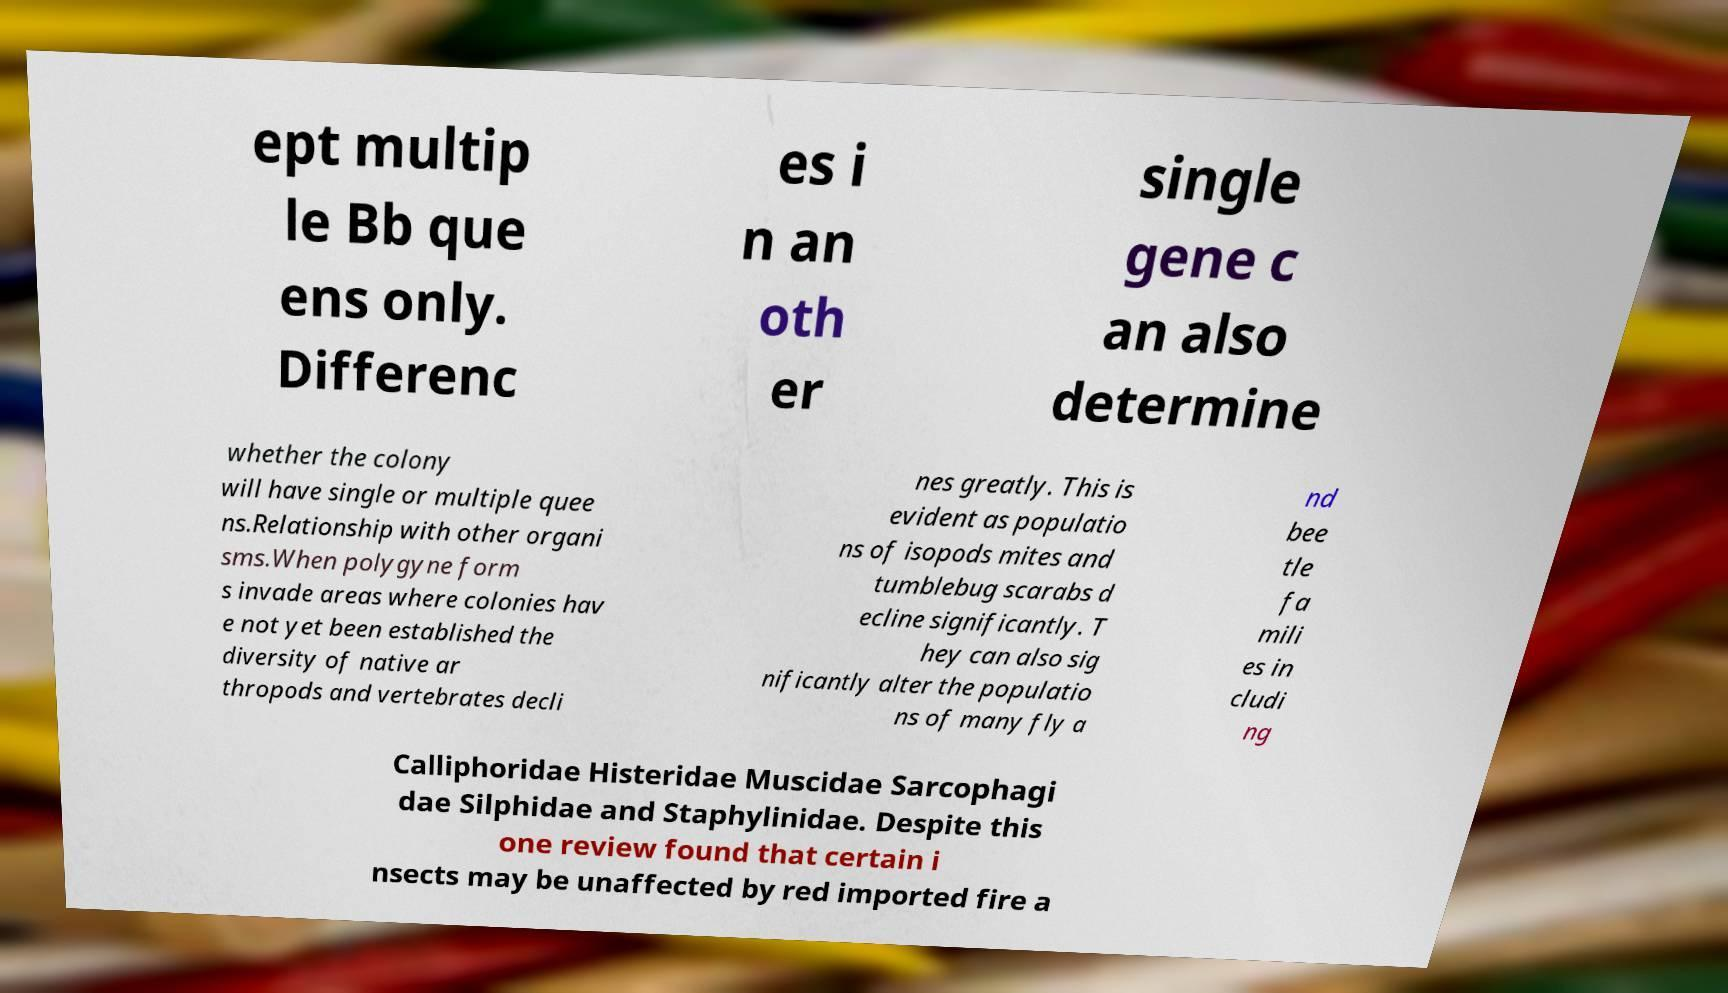Please read and relay the text visible in this image. What does it say? ept multip le Bb que ens only. Differenc es i n an oth er single gene c an also determine whether the colony will have single or multiple quee ns.Relationship with other organi sms.When polygyne form s invade areas where colonies hav e not yet been established the diversity of native ar thropods and vertebrates decli nes greatly. This is evident as populatio ns of isopods mites and tumblebug scarabs d ecline significantly. T hey can also sig nificantly alter the populatio ns of many fly a nd bee tle fa mili es in cludi ng Calliphoridae Histeridae Muscidae Sarcophagi dae Silphidae and Staphylinidae. Despite this one review found that certain i nsects may be unaffected by red imported fire a 